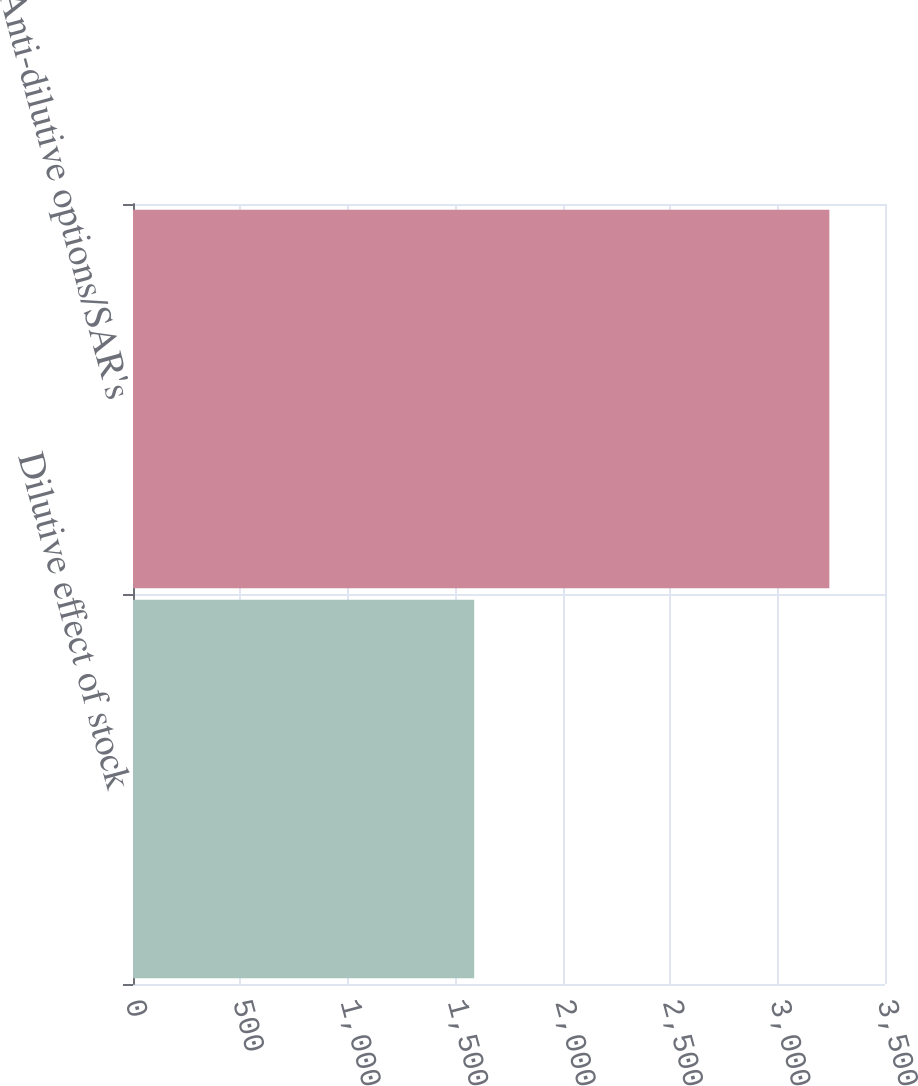Convert chart to OTSL. <chart><loc_0><loc_0><loc_500><loc_500><bar_chart><fcel>Dilutive effect of stock<fcel>Anti-dilutive options/SAR's<nl><fcel>1588<fcel>3241<nl></chart> 